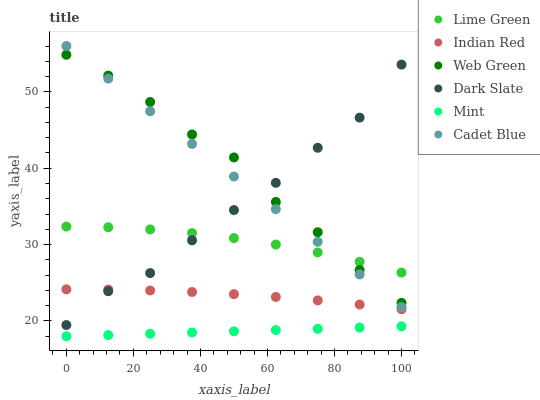Does Mint have the minimum area under the curve?
Answer yes or no. Yes. Does Web Green have the maximum area under the curve?
Answer yes or no. Yes. Does Lime Green have the minimum area under the curve?
Answer yes or no. No. Does Lime Green have the maximum area under the curve?
Answer yes or no. No. Is Mint the smoothest?
Answer yes or no. Yes. Is Dark Slate the roughest?
Answer yes or no. Yes. Is Lime Green the smoothest?
Answer yes or no. No. Is Lime Green the roughest?
Answer yes or no. No. Does Mint have the lowest value?
Answer yes or no. Yes. Does Web Green have the lowest value?
Answer yes or no. No. Does Cadet Blue have the highest value?
Answer yes or no. Yes. Does Lime Green have the highest value?
Answer yes or no. No. Is Indian Red less than Cadet Blue?
Answer yes or no. Yes. Is Indian Red greater than Mint?
Answer yes or no. Yes. Does Web Green intersect Dark Slate?
Answer yes or no. Yes. Is Web Green less than Dark Slate?
Answer yes or no. No. Is Web Green greater than Dark Slate?
Answer yes or no. No. Does Indian Red intersect Cadet Blue?
Answer yes or no. No. 